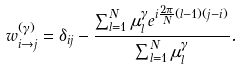<formula> <loc_0><loc_0><loc_500><loc_500>w _ { i \to j } ^ { ( \gamma ) } = \delta _ { i j } - \frac { \sum _ { l = 1 } ^ { N } \mu _ { l } ^ { \gamma } e ^ { i \frac { 2 \pi } { N } ( l - 1 ) ( j - i ) } } { \sum _ { l = 1 } ^ { N } \mu _ { l } ^ { \gamma } } .</formula> 